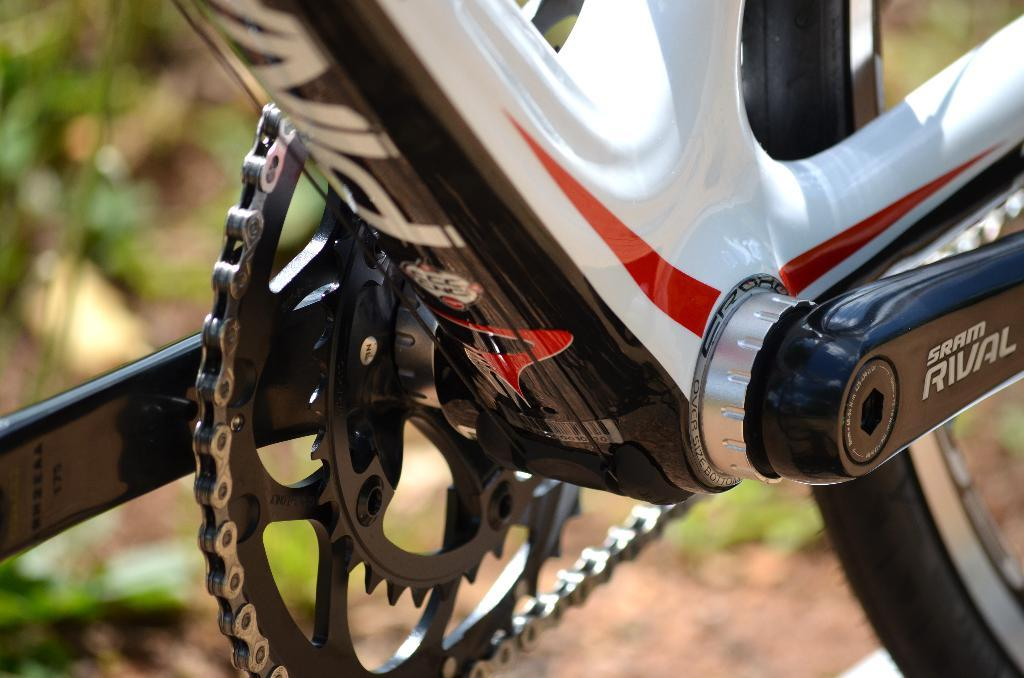What is the main subject in the center of the image? There is a bicycle in the center of the image. What can be seen in the background of the image? There are leaves in the background of the image. What type of surface is visible at the bottom of the image? There is a road at the bottom of the image. What type of jail can be seen in the image? There is no jail present in the image. What thrilling activity is happening in the image? The image does not depict any specific activity or thrill. 